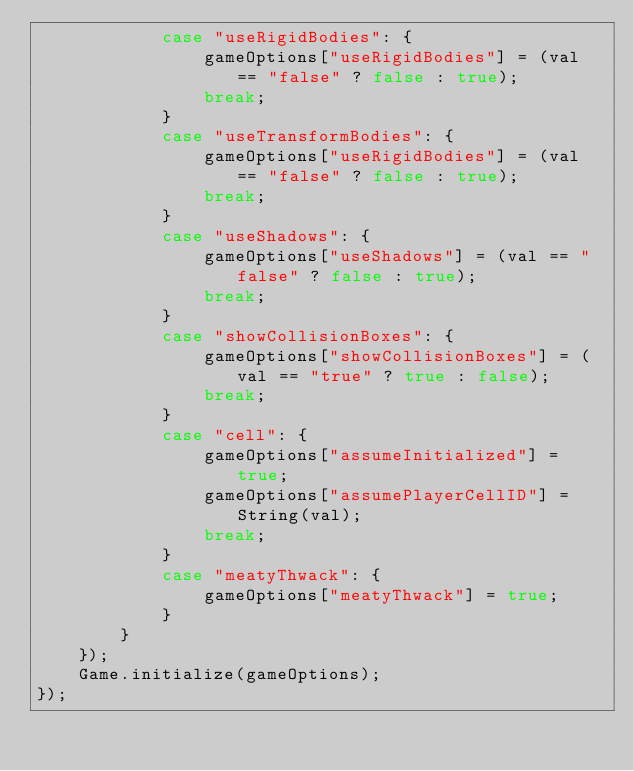<code> <loc_0><loc_0><loc_500><loc_500><_JavaScript_>            case "useRigidBodies": {
                gameOptions["useRigidBodies"] = (val == "false" ? false : true);
                break;
            }
            case "useTransformBodies": {
                gameOptions["useRigidBodies"] = (val == "false" ? false : true);
                break;
            }
            case "useShadows": {
                gameOptions["useShadows"] = (val == "false" ? false : true);
                break;
            }
            case "showCollisionBoxes": {
                gameOptions["showCollisionBoxes"] = (val == "true" ? true : false);
                break;
            }
            case "cell": {
                gameOptions["assumeInitialized"] = true;
                gameOptions["assumePlayerCellID"] = String(val);
                break;
            }
            case "meatyThwack": {
                gameOptions["meatyThwack"] = true;
            }
        }
    });
    Game.initialize(gameOptions);
});</code> 